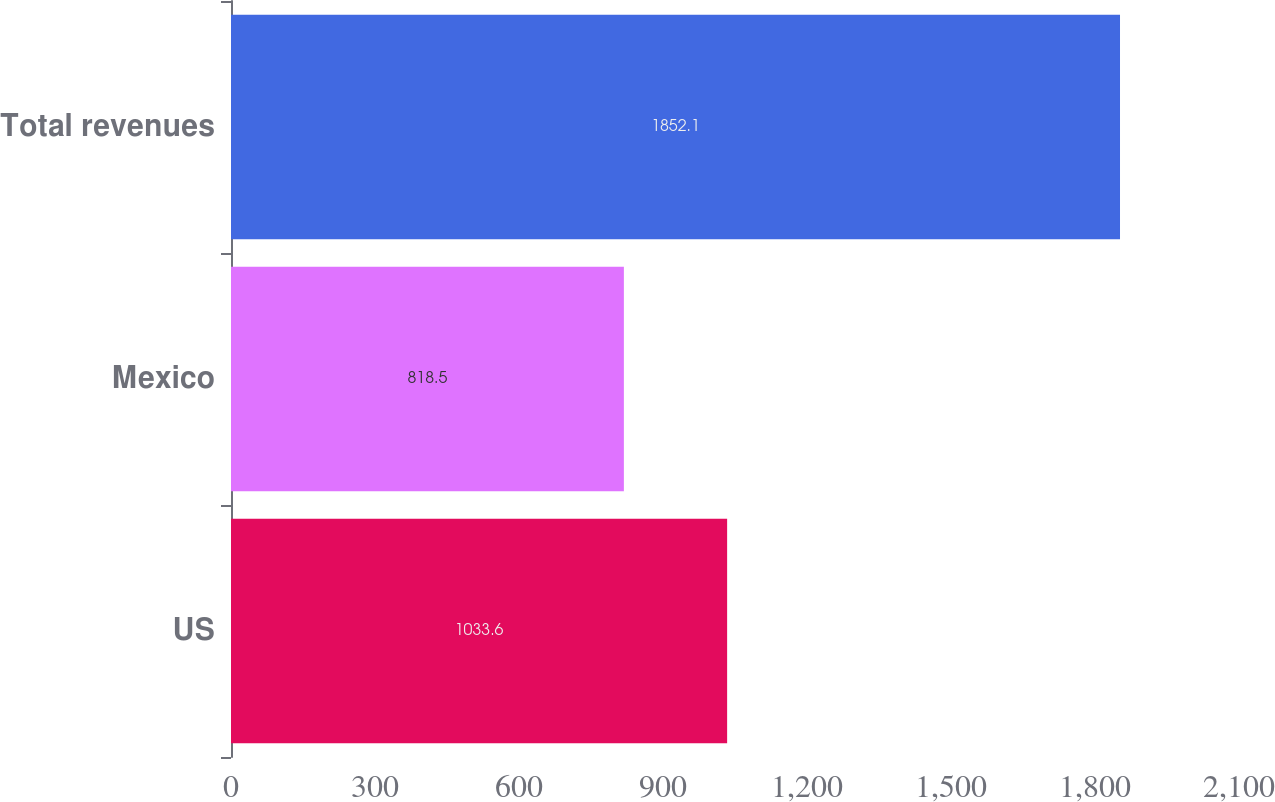Convert chart. <chart><loc_0><loc_0><loc_500><loc_500><bar_chart><fcel>US<fcel>Mexico<fcel>Total revenues<nl><fcel>1033.6<fcel>818.5<fcel>1852.1<nl></chart> 